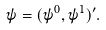Convert formula to latex. <formula><loc_0><loc_0><loc_500><loc_500>\psi = ( \psi ^ { 0 } , \psi ^ { 1 } ) ^ { \prime } .</formula> 